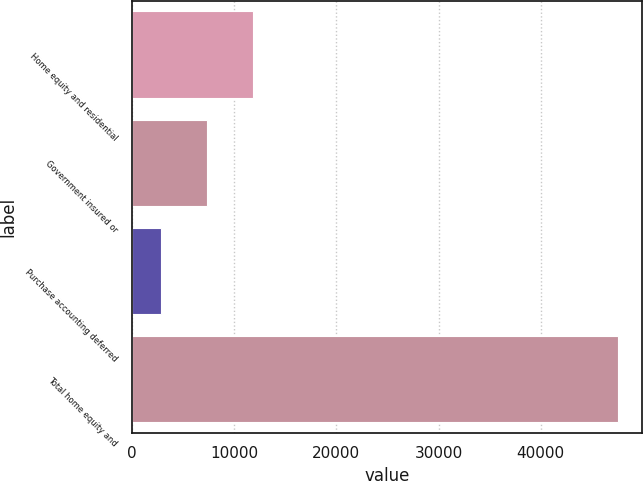Convert chart to OTSL. <chart><loc_0><loc_0><loc_500><loc_500><bar_chart><fcel>Home equity and residential<fcel>Government insured or<fcel>Purchase accounting deferred<fcel>Total home equity and<nl><fcel>11810<fcel>7341.5<fcel>2873<fcel>47558<nl></chart> 